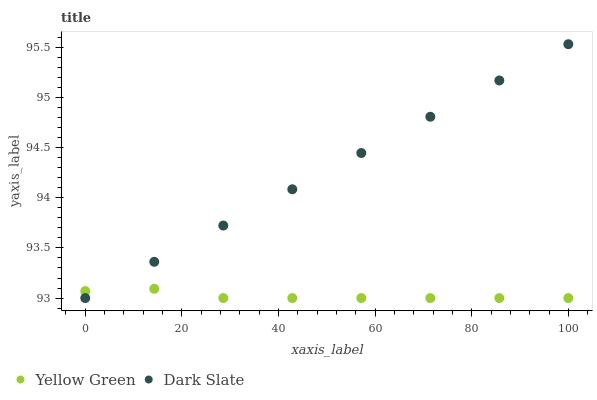Does Yellow Green have the minimum area under the curve?
Answer yes or no. Yes. Does Dark Slate have the maximum area under the curve?
Answer yes or no. Yes. Does Yellow Green have the maximum area under the curve?
Answer yes or no. No. Is Dark Slate the smoothest?
Answer yes or no. Yes. Is Yellow Green the roughest?
Answer yes or no. Yes. Is Yellow Green the smoothest?
Answer yes or no. No. Does Dark Slate have the lowest value?
Answer yes or no. Yes. Does Dark Slate have the highest value?
Answer yes or no. Yes. Does Yellow Green have the highest value?
Answer yes or no. No. Does Dark Slate intersect Yellow Green?
Answer yes or no. Yes. Is Dark Slate less than Yellow Green?
Answer yes or no. No. Is Dark Slate greater than Yellow Green?
Answer yes or no. No. 